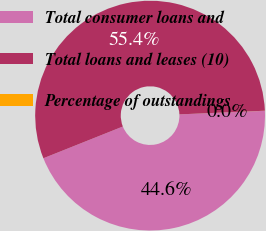Convert chart to OTSL. <chart><loc_0><loc_0><loc_500><loc_500><pie_chart><fcel>Total consumer loans and<fcel>Total loans and leases (10)<fcel>Percentage of outstandings<nl><fcel>44.62%<fcel>55.37%<fcel>0.01%<nl></chart> 